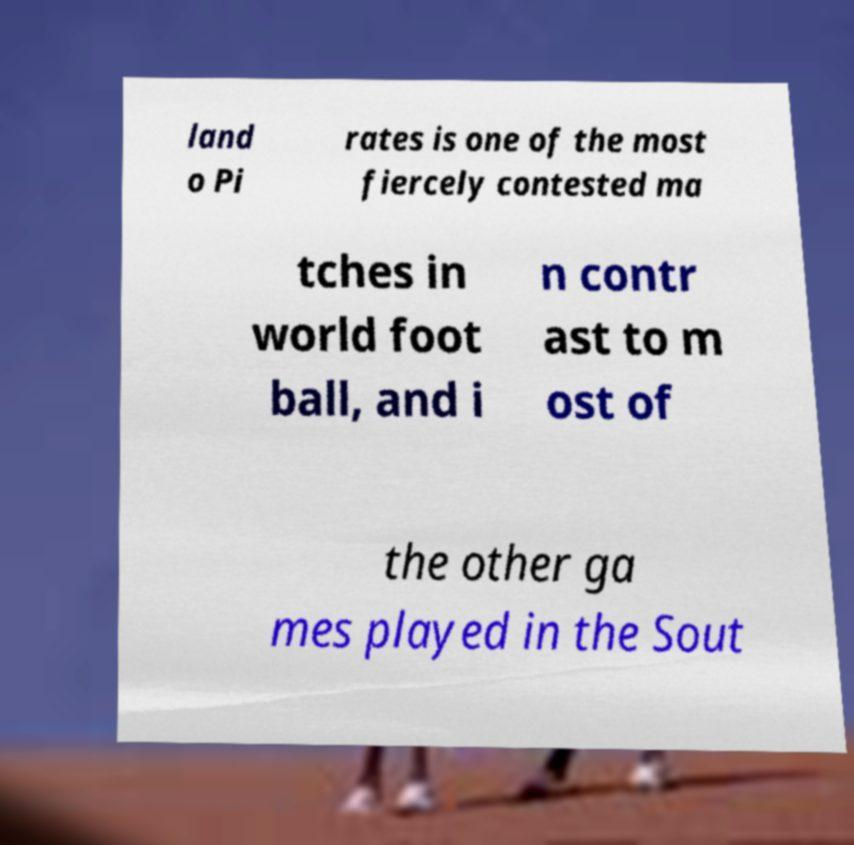Could you assist in decoding the text presented in this image and type it out clearly? land o Pi rates is one of the most fiercely contested ma tches in world foot ball, and i n contr ast to m ost of the other ga mes played in the Sout 